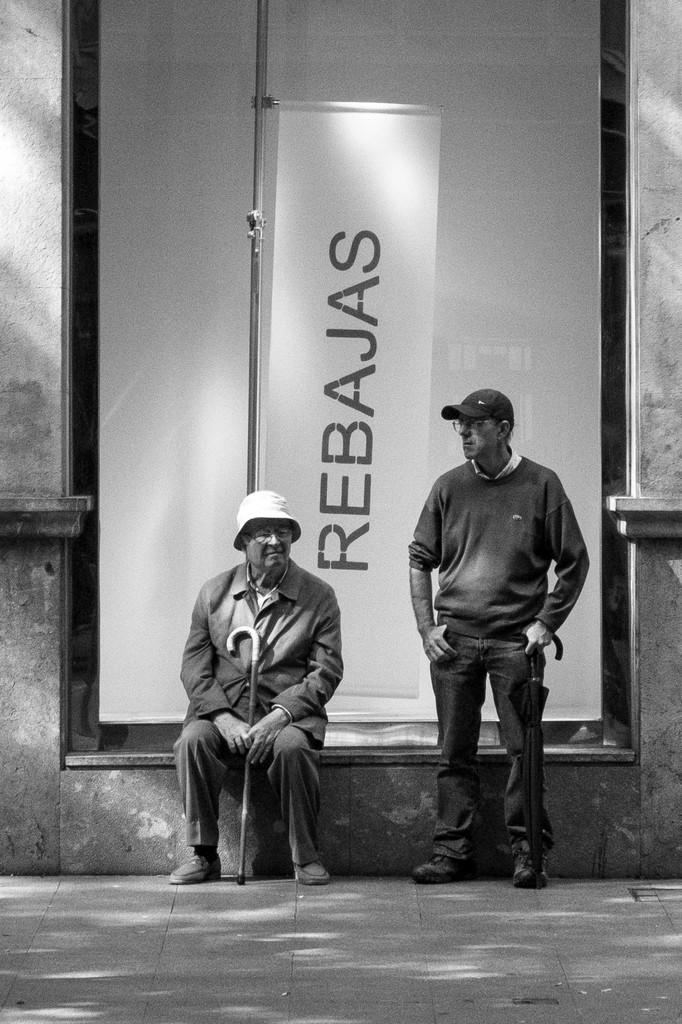What is the position of the person in the image? A: There is a person sitting in the image. What is the sitting person holding? The sitting person is holding a stick. What is the position of the other person in the image? There is a person standing in the image. What is the standing person holding? The standing person is holding an umbrella. What can be seen in the background of the image? There is a hoarding at the back of the scene and a building visible in the image. What type of desk can be seen in the image? There is no desk present in the image. Can you hear the whistle of the wind in the image? The image is a still picture, so there is no sound or wind to whistle. --- Facts: 1. There is a person standing on a bridge in the image. 2. The person is holding a camera. 3. The bridge is over a river. 4. There are trees on both sides of the river. 5. The sky is visible in the image. Absurd Topics: parrot, volleyball, fireworks Conversation: What is the person in the image doing? There is a person standing on a bridge in the image. What is the person holding? The person is holding a camera. What is the bridge positioned over? The bridge is over a river. What can be seen on both sides of the river? There are trees on both sides of the river. What is visible in the background of the image? The sky is visible in the image. Reasoning: Let's think step by step in order to produce the conversation. We start by identifying the main subject in the image, which is the person standing on the bridge. Then, we describe what the person is holding, which is a camera. Next, we mention the location of the bridge, which is over a river, and the surrounding environment, which includes trees on both sides. Finally, we mention the background element, which is the sky. Each question is designed to elicit a specific detail about the image that is known from the provided facts provided. Absurd Question/Answer: Can you see a parrot flying over the river in the image? There is: There is no parrot present in the image. Is there a volleyball game happening on the bridge in the image? There is no volleyball game or any indication of a sporting event in the image. 